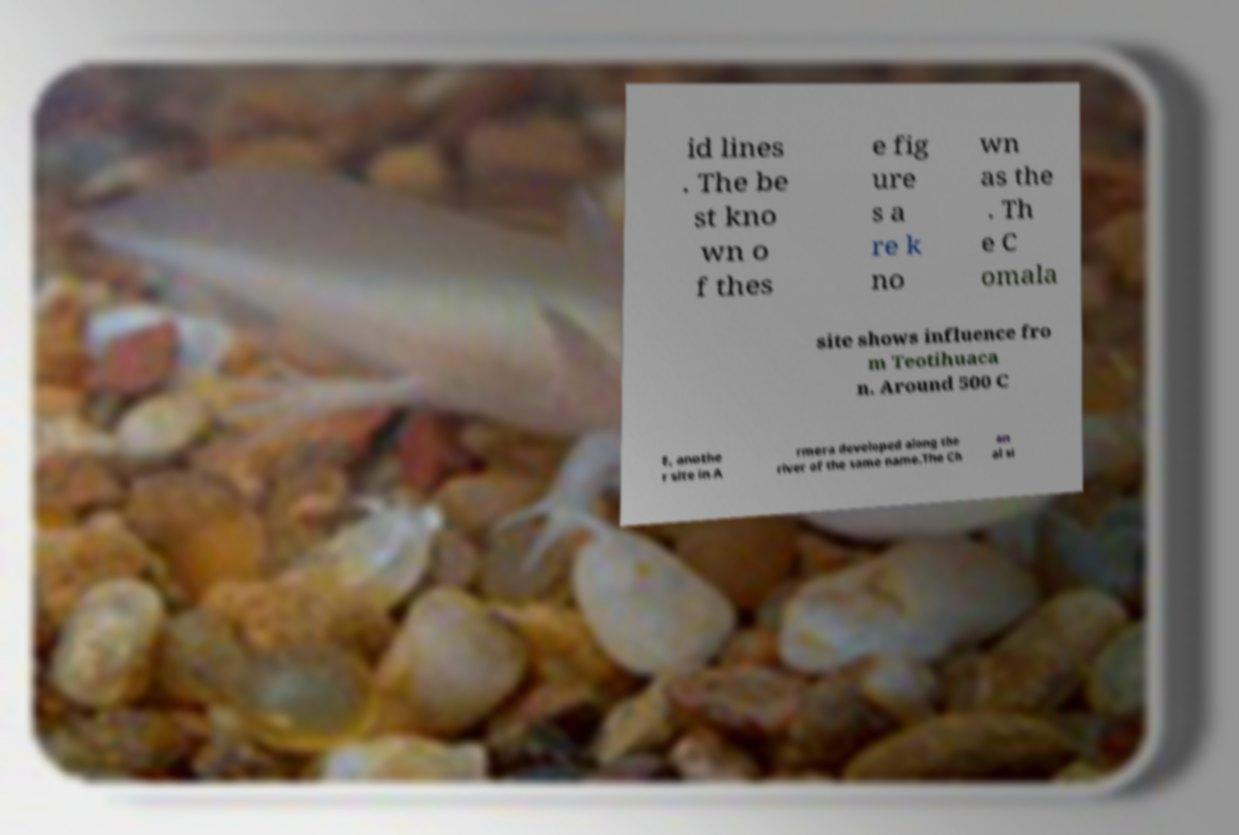Please read and relay the text visible in this image. What does it say? id lines . The be st kno wn o f thes e fig ure s a re k no wn as the . Th e C omala site shows influence fro m Teotihuaca n. Around 500 C E, anothe r site in A rmera developed along the river of the same name.The Ch an al si 